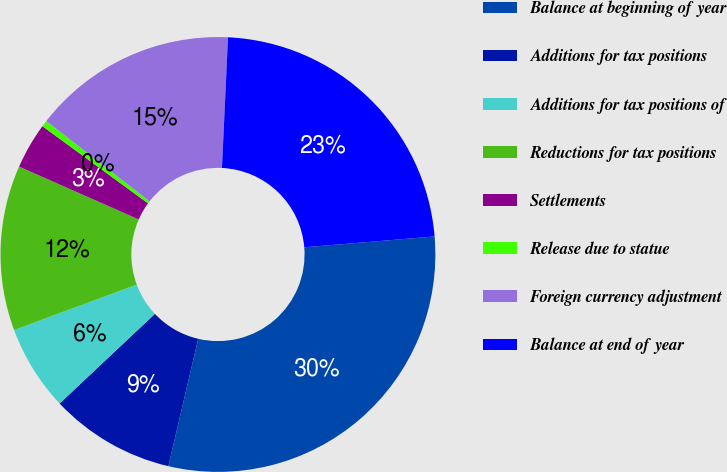Convert chart to OTSL. <chart><loc_0><loc_0><loc_500><loc_500><pie_chart><fcel>Balance at beginning of year<fcel>Additions for tax positions<fcel>Additions for tax positions of<fcel>Reductions for tax positions<fcel>Settlements<fcel>Release due to statue<fcel>Foreign currency adjustment<fcel>Balance at end of year<nl><fcel>29.98%<fcel>9.32%<fcel>6.37%<fcel>12.27%<fcel>3.42%<fcel>0.47%<fcel>15.22%<fcel>22.94%<nl></chart> 